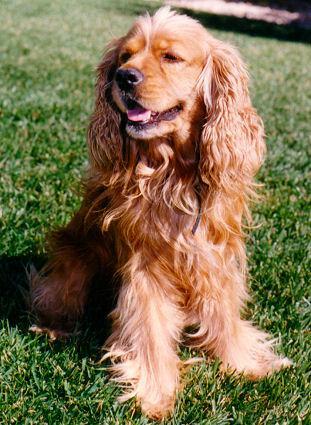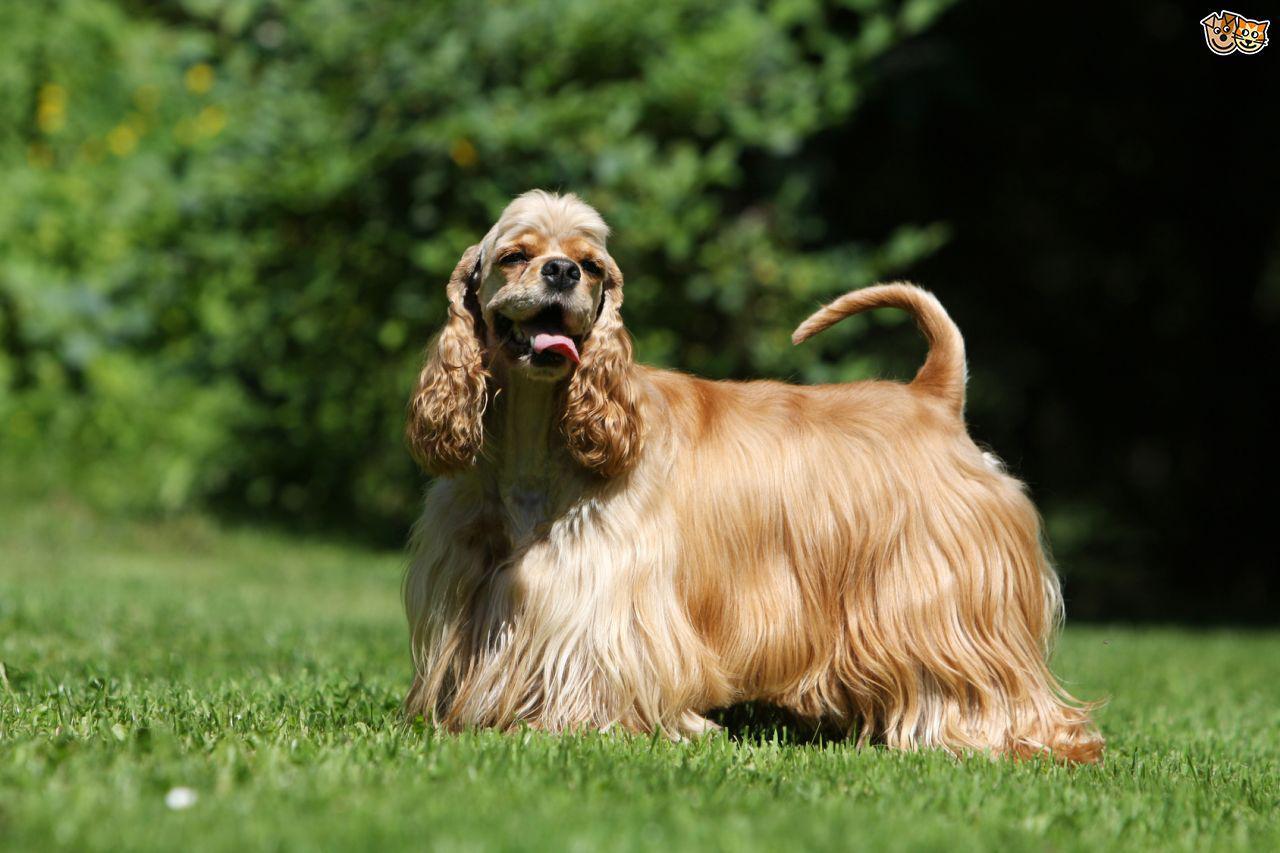The first image is the image on the left, the second image is the image on the right. Analyze the images presented: Is the assertion "One dog is sitting down while the other dog is standing on all fours" valid? Answer yes or no. Yes. The first image is the image on the left, the second image is the image on the right. Examine the images to the left and right. Is the description "One image shows a golden-colored cocker spaniel standing on the grass, body turned to the left." accurate? Answer yes or no. Yes. 